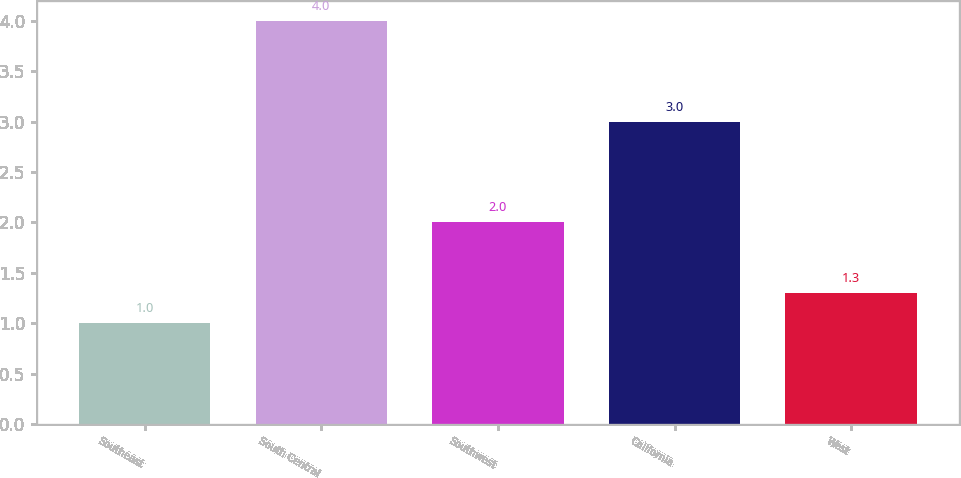Convert chart to OTSL. <chart><loc_0><loc_0><loc_500><loc_500><bar_chart><fcel>Southeast<fcel>South Central<fcel>Southwest<fcel>California<fcel>West<nl><fcel>1<fcel>4<fcel>2<fcel>3<fcel>1.3<nl></chart> 